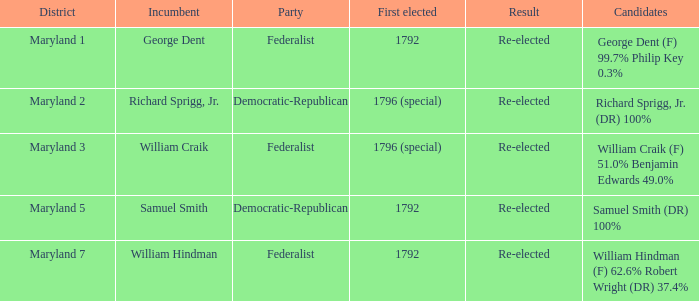0%? Maryland 3. 